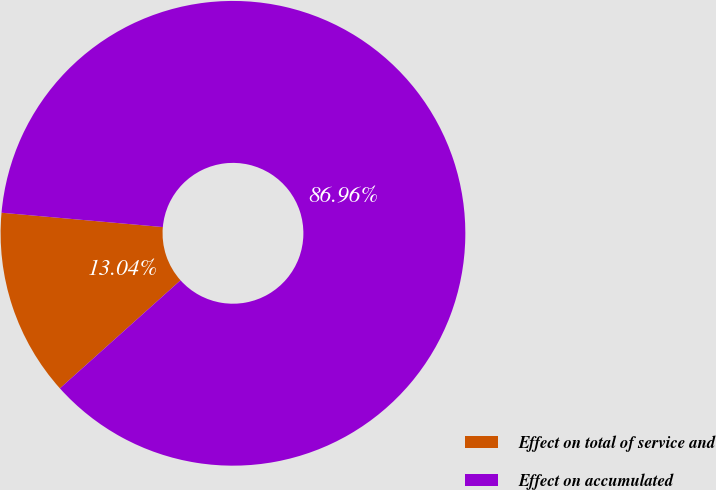Convert chart to OTSL. <chart><loc_0><loc_0><loc_500><loc_500><pie_chart><fcel>Effect on total of service and<fcel>Effect on accumulated<nl><fcel>13.04%<fcel>86.96%<nl></chart> 